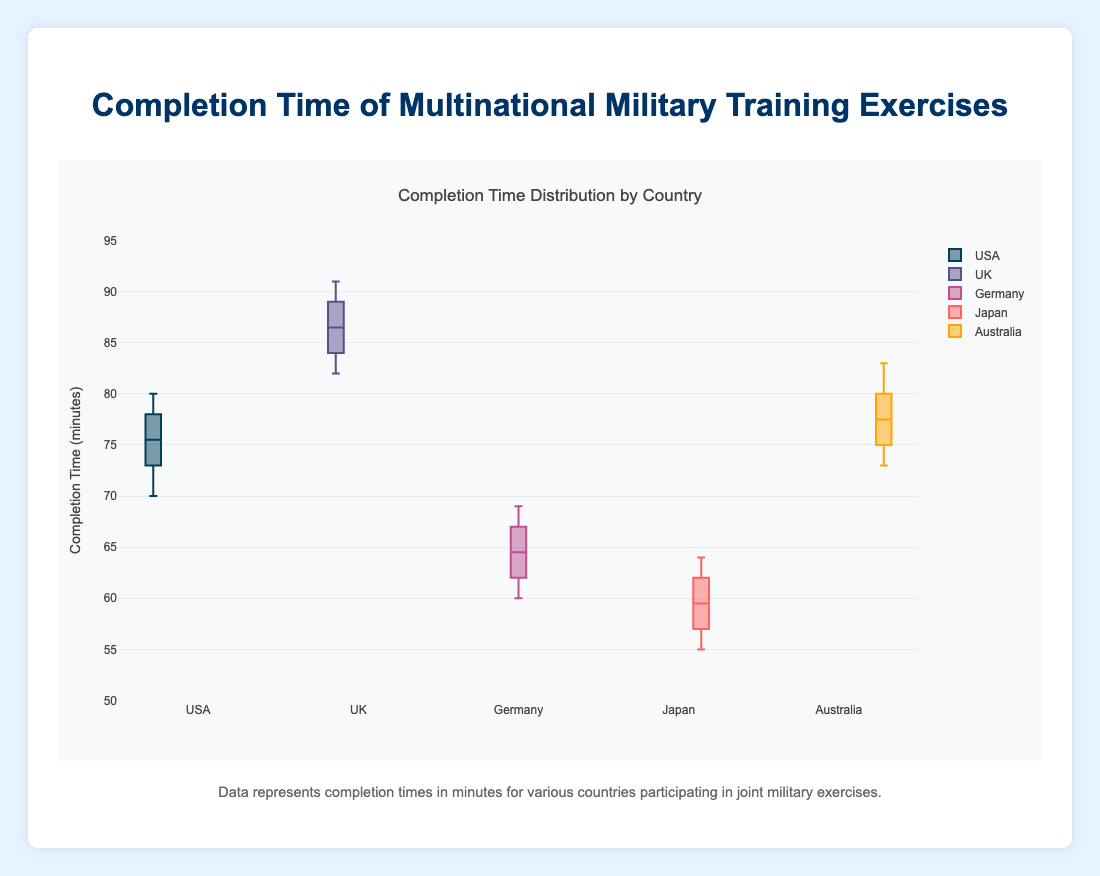How many countries are included in the box plot? The title of the plot mentions "Completion Time Distribution by Country" and there are five different box plots, each representing a different country: USA, UK, Germany, Japan, and Australia.
Answer: 5 What is the range of completion times for the UK? From the box plot for the UK, we see that the minimum value (lower whisker) is 82 and the maximum value (upper whisker) is 91.
Answer: 82 to 91 Which country has the lowest median completion time? Observing the median lines (middle lines) within each box plot, Japan's median appears at the lowest point.
Answer: Japan What is the interquartile range (IQR) of completion times for Germany? The IQR is calculated by subtracting the first quartile (Q1) from the third quartile (Q3). For Germany, Q1 is 61 and Q3 is 67, so IQR = 67 - 61.
Answer: 6 Which country shows the greatest spread (range) in its completion times? The range is the difference between the maximum and minimum values (whiskers) of each box plot. The UK has the greatest spread with maximum 91 and minimum 82, resulting in a range of 9.
Answer: UK How does the median completion time for the USA compare to Australia? Comparing the median lines for both boxes, the median for the USA is slightly lower than that for Australia.
Answer: USA < Australia What is the median completion time for the USA? Observing the midpoint line within the USA's box plot, the median value is approximately at 75.
Answer: 75 Which country has the smallest interquartile range (IQR)? By comparing the lengths of the boxes (IQR) for each country, Japan's box is the smallest, indicating the smallest IQR.
Answer: Japan Are there any outliers in the completion times for any country? The plot elements don't show any individual points outside the whiskers of the box plots, indicating no outliers for any country.
Answer: No Which country has the highest median completion time? Observing the median lines within each box plot, the UK has the highest median point.
Answer: UK 